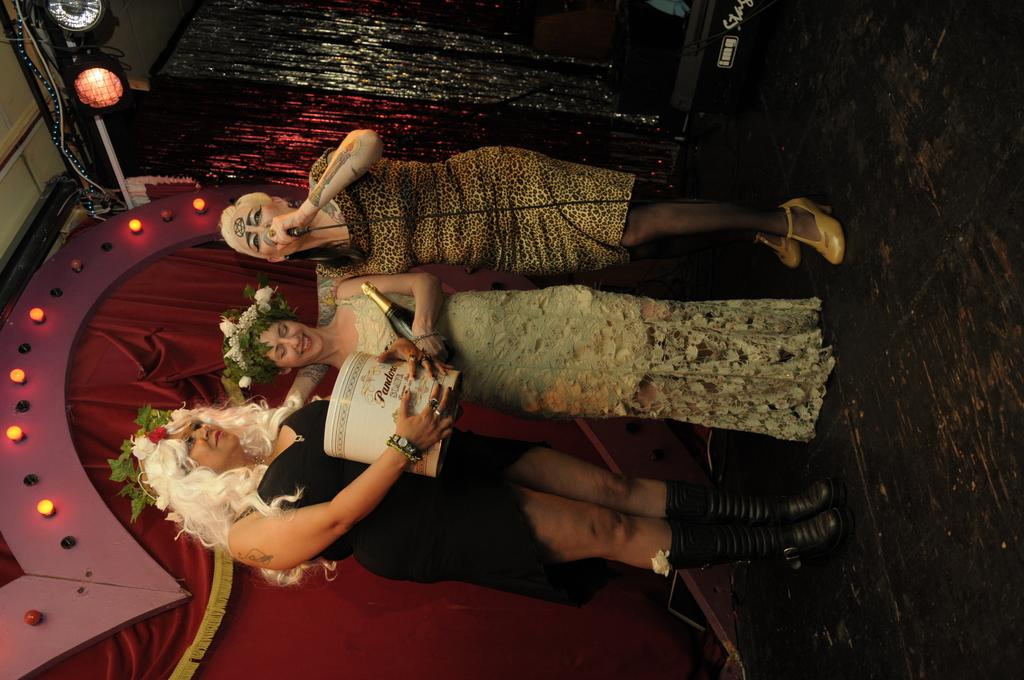How many women are in the image? There are three women in the image. What is the middle woman holding? The middle woman is holding a bottle. What is the woman on the right side holding? The woman on the right side is holding a microphone. What can be seen in the background of the image? There are lights and curtains visible in the background of the image. What type of fish can be seen swimming on the floor in the image? There is no fish or floor present in the image; it features three women and a background with lights and curtains. 